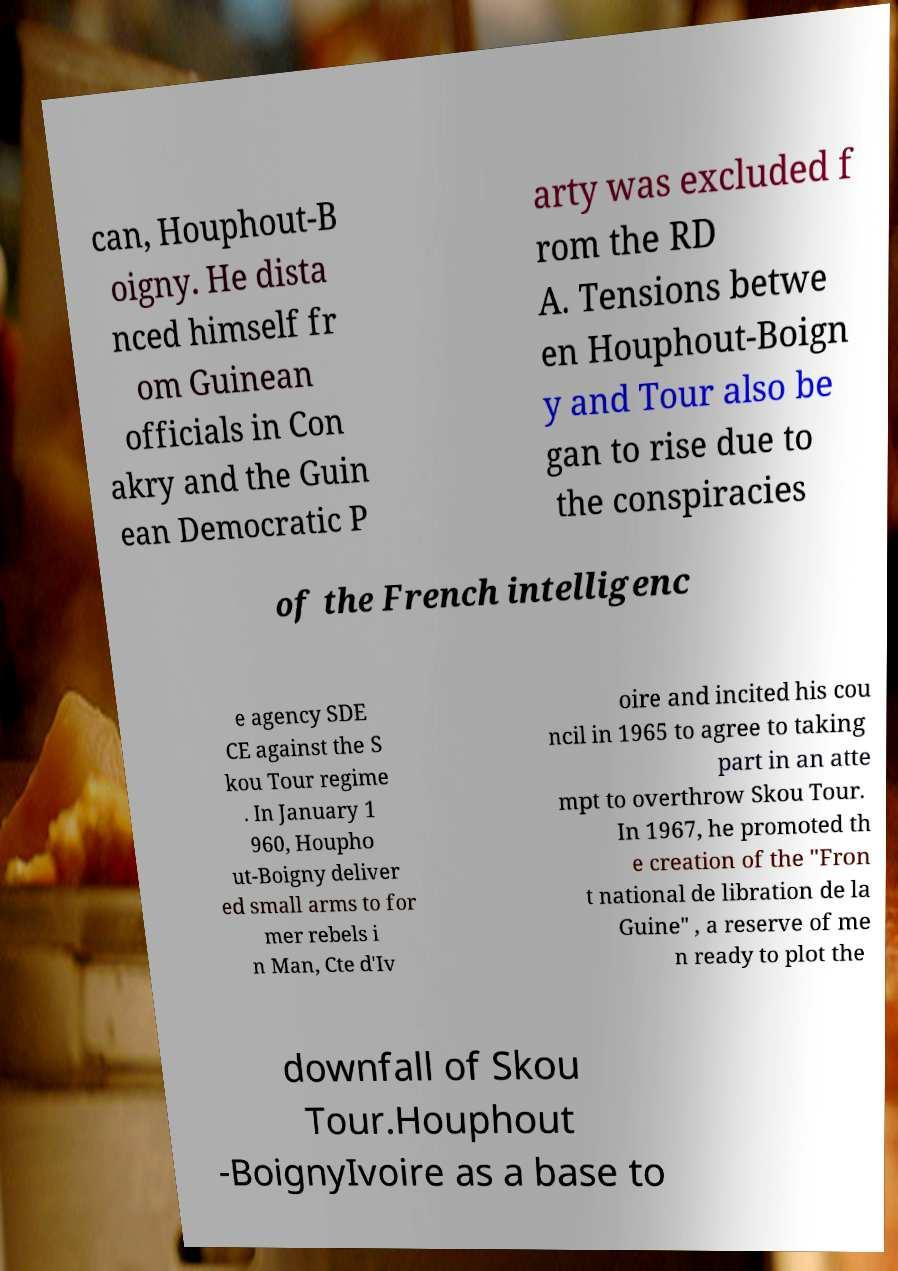Please identify and transcribe the text found in this image. can, Houphout-B oigny. He dista nced himself fr om Guinean officials in Con akry and the Guin ean Democratic P arty was excluded f rom the RD A. Tensions betwe en Houphout-Boign y and Tour also be gan to rise due to the conspiracies of the French intelligenc e agency SDE CE against the S kou Tour regime . In January 1 960, Houpho ut-Boigny deliver ed small arms to for mer rebels i n Man, Cte d'Iv oire and incited his cou ncil in 1965 to agree to taking part in an atte mpt to overthrow Skou Tour. In 1967, he promoted th e creation of the "Fron t national de libration de la Guine" , a reserve of me n ready to plot the downfall of Skou Tour.Houphout -BoignyIvoire as a base to 